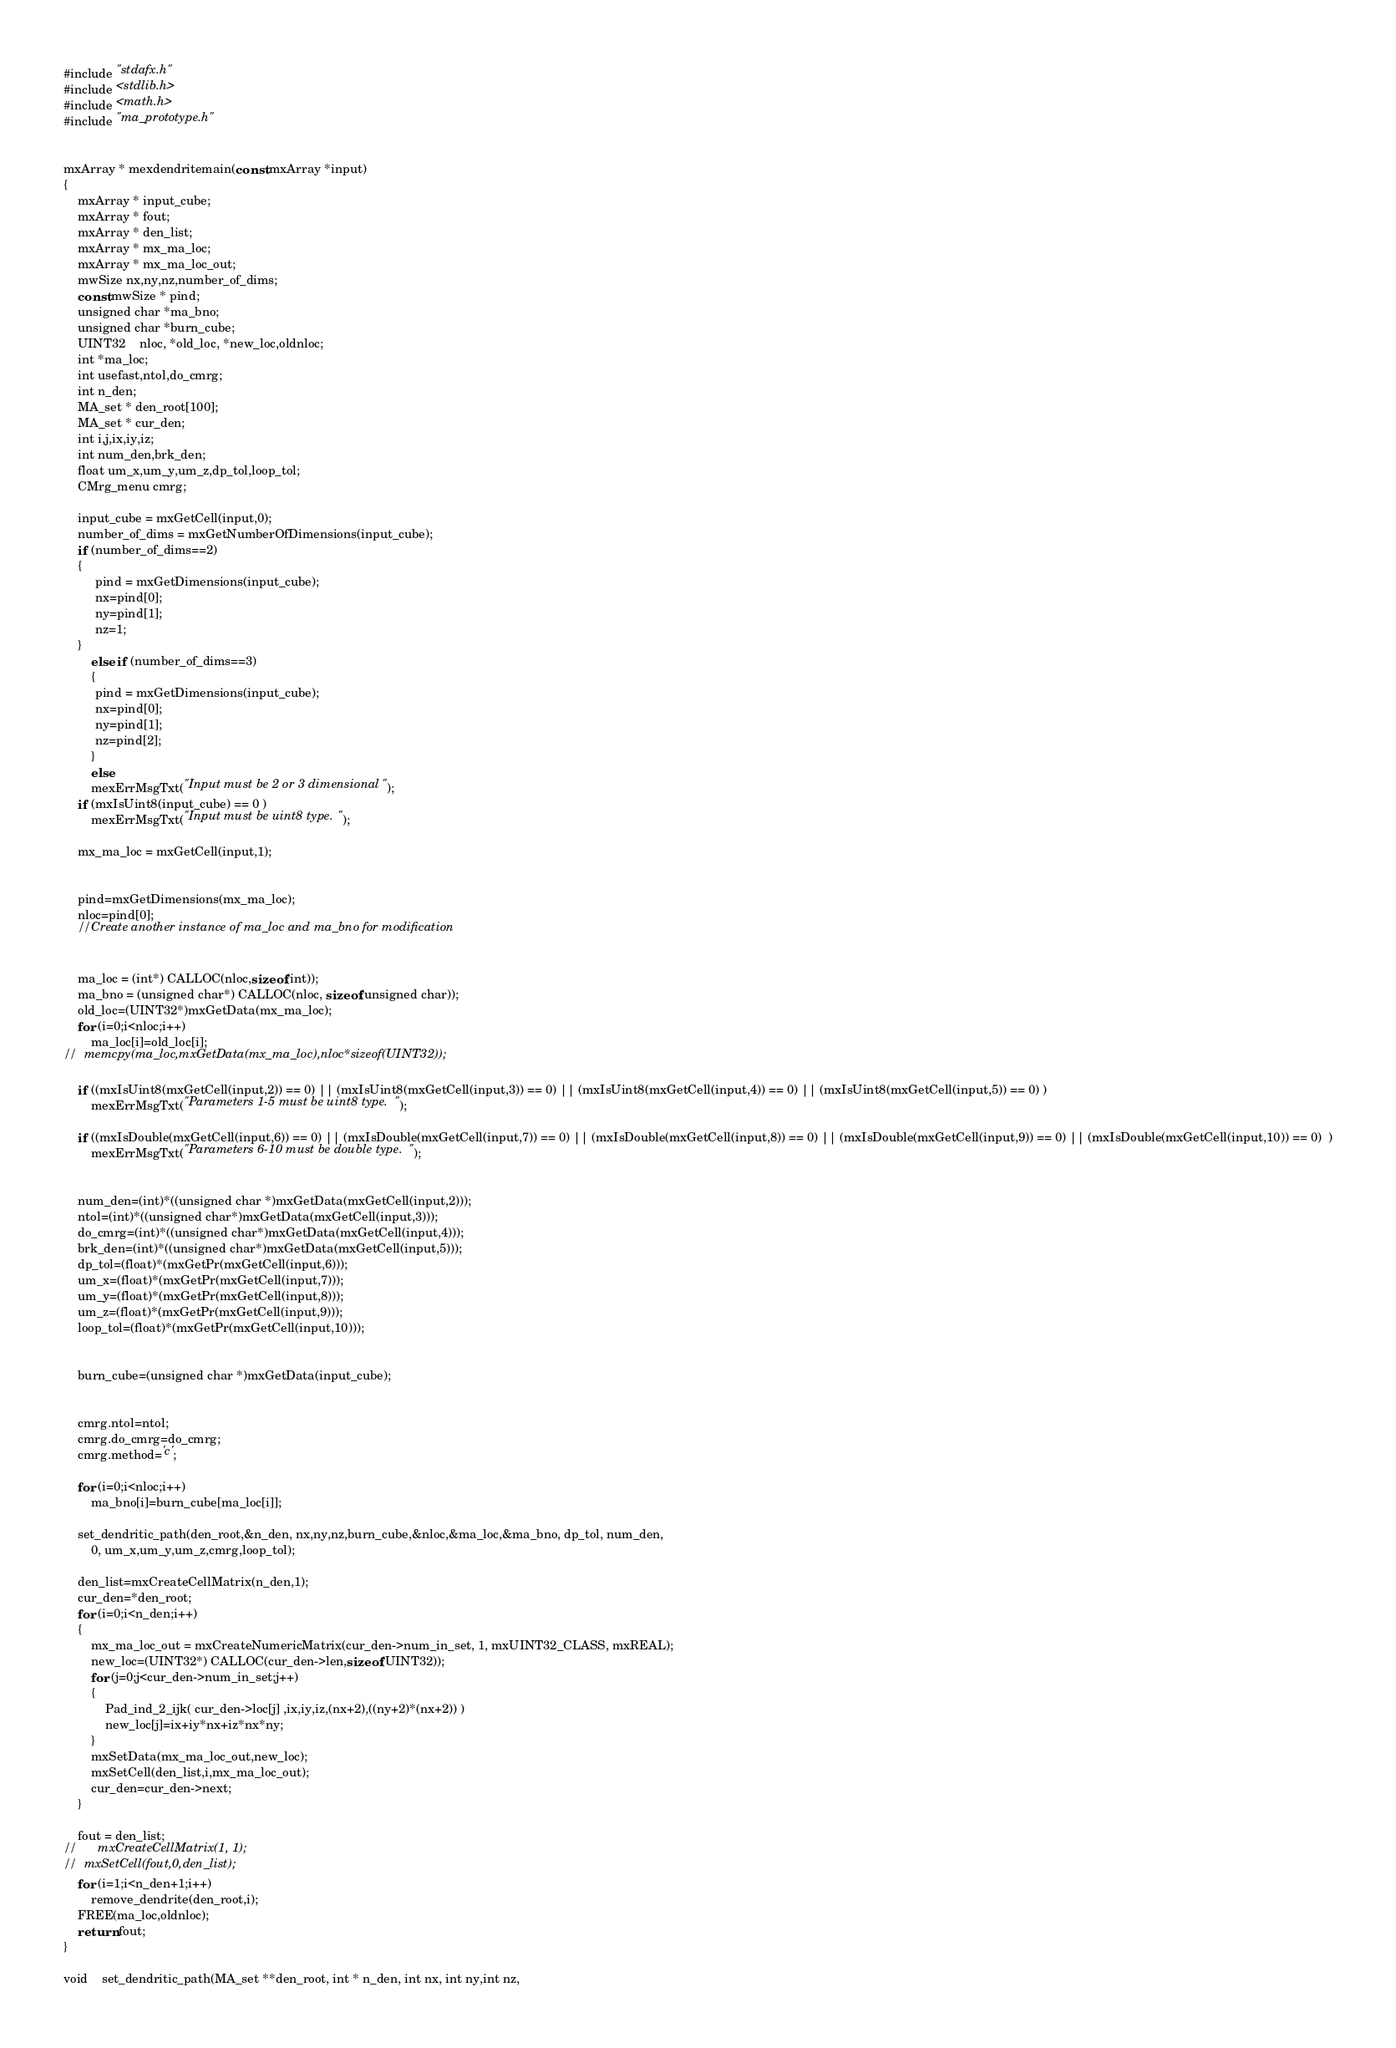Convert code to text. <code><loc_0><loc_0><loc_500><loc_500><_C_>#include "stdafx.h"
#include <stdlib.h>
#include <math.h>
#include "ma_prototype.h"


mxArray * mexdendritemain(const mxArray *input)
{
	mxArray * input_cube; 
	mxArray * fout;
	mxArray * den_list;
	mxArray * mx_ma_loc;
	mxArray * mx_ma_loc_out;
	mwSize nx,ny,nz,number_of_dims;
	const mwSize * pind;
	unsigned char *ma_bno;
	unsigned char *burn_cube;
	UINT32	nloc, *old_loc, *new_loc,oldnloc;
	int *ma_loc;
	int usefast,ntol,do_cmrg;
	int n_den;
	MA_set * den_root[100];
	MA_set * cur_den;
	int i,j,ix,iy,iz;
	int num_den,brk_den;
	float um_x,um_y,um_z,dp_tol,loop_tol;
	CMrg_menu cmrg;

	input_cube = mxGetCell(input,0);
	number_of_dims = mxGetNumberOfDimensions(input_cube);
	if (number_of_dims==2)
	{
		 pind = mxGetDimensions(input_cube);
		 nx=pind[0];
		 ny=pind[1];
		 nz=1;
	}
		else if (number_of_dims==3)
		{
		 pind = mxGetDimensions(input_cube);
		 nx=pind[0];
		 ny=pind[1];
		 nz=pind[2];
		}
		else
		mexErrMsgTxt("Input must be 2 or 3 dimensional");
	if (mxIsUint8(input_cube) == 0 )
		mexErrMsgTxt("Input must be uint8 type.");

	mx_ma_loc = mxGetCell(input,1);

	
	pind=mxGetDimensions(mx_ma_loc);
	nloc=pind[0];
	//Create another instance of ma_loc and ma_bno for modification


	ma_loc = (int*) CALLOC(nloc,sizeof(int));
	ma_bno = (unsigned char*) CALLOC(nloc, sizeof(unsigned char));
	old_loc=(UINT32*)mxGetData(mx_ma_loc);
	for (i=0;i<nloc;i++)
		ma_loc[i]=old_loc[i];
//	memcpy(ma_loc,mxGetData(mx_ma_loc),nloc*sizeof(UINT32));
	
	if ((mxIsUint8(mxGetCell(input,2)) == 0) || (mxIsUint8(mxGetCell(input,3)) == 0) || (mxIsUint8(mxGetCell(input,4)) == 0) || (mxIsUint8(mxGetCell(input,5)) == 0) )
		mexErrMsgTxt("Parameters 1-5 must be uint8 type.");

	if ((mxIsDouble(mxGetCell(input,6)) == 0) || (mxIsDouble(mxGetCell(input,7)) == 0) || (mxIsDouble(mxGetCell(input,8)) == 0) || (mxIsDouble(mxGetCell(input,9)) == 0) || (mxIsDouble(mxGetCell(input,10)) == 0)  )
		mexErrMsgTxt("Parameters 6-10 must be double type.");


	num_den=(int)*((unsigned char *)mxGetData(mxGetCell(input,2)));
	ntol=(int)*((unsigned char*)mxGetData(mxGetCell(input,3)));
	do_cmrg=(int)*((unsigned char*)mxGetData(mxGetCell(input,4)));
	brk_den=(int)*((unsigned char*)mxGetData(mxGetCell(input,5)));
	dp_tol=(float)*(mxGetPr(mxGetCell(input,6)));
	um_x=(float)*(mxGetPr(mxGetCell(input,7)));
	um_y=(float)*(mxGetPr(mxGetCell(input,8)));
	um_z=(float)*(mxGetPr(mxGetCell(input,9)));
	loop_tol=(float)*(mxGetPr(mxGetCell(input,10)));


	burn_cube=(unsigned char *)mxGetData(input_cube);

	
	cmrg.ntol=ntol;
	cmrg.do_cmrg=do_cmrg;
	cmrg.method='c';

	for (i=0;i<nloc;i++)
		ma_bno[i]=burn_cube[ma_loc[i]];

	set_dendritic_path(den_root,&n_den, nx,ny,nz,burn_cube,&nloc,&ma_loc,&ma_bno, dp_tol, num_den,
		0, um_x,um_y,um_z,cmrg,loop_tol);

	den_list=mxCreateCellMatrix(n_den,1);
	cur_den=*den_root;
	for (i=0;i<n_den;i++)
	{
		mx_ma_loc_out = mxCreateNumericMatrix(cur_den->num_in_set, 1, mxUINT32_CLASS, mxREAL);
		new_loc=(UINT32*) CALLOC(cur_den->len,sizeof(UINT32));
		for (j=0;j<cur_den->num_in_set;j++)
		{
			Pad_ind_2_ijk( cur_den->loc[j] ,ix,iy,iz,(nx+2),((ny+2)*(nx+2)) )		
			new_loc[j]=ix+iy*nx+iz*nx*ny;
		}
		mxSetData(mx_ma_loc_out,new_loc);
		mxSetCell(den_list,i,mx_ma_loc_out);
		cur_den=cur_den->next;
	}

	fout = den_list;
//		mxCreateCellMatrix(1, 1);
//	mxSetCell(fout,0,den_list);
	for (i=1;i<n_den+1;i++)
		remove_dendrite(den_root,i);
	FREE(ma_loc,oldnloc);
	return fout;
}

void	set_dendritic_path(MA_set **den_root, int * n_den, int nx, int ny,int nz,</code> 